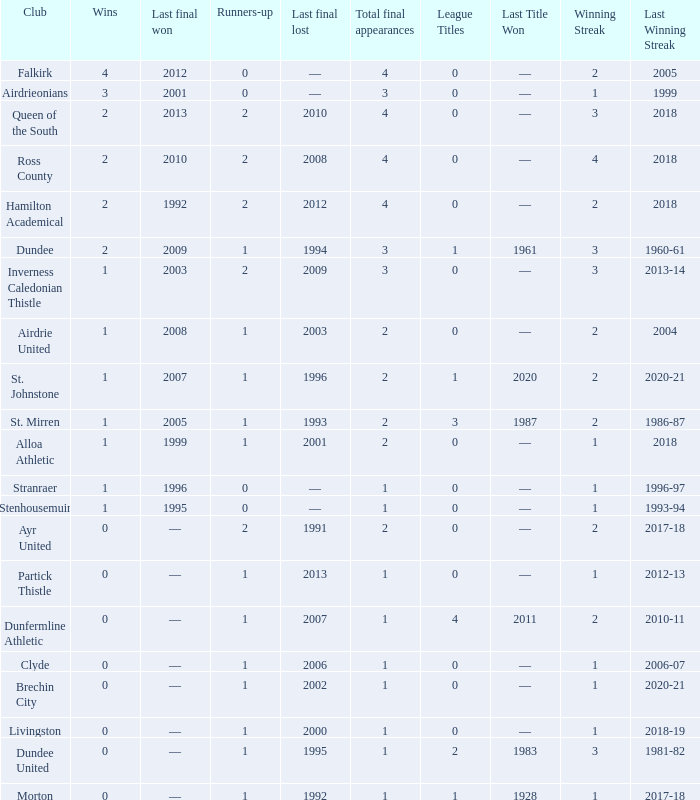What club has over 1 runners-up and last won the final in 2010? Ross County. Parse the full table. {'header': ['Club', 'Wins', 'Last final won', 'Runners-up', 'Last final lost', 'Total final appearances', 'League Titles', 'Last Title Won', 'Winning Streak', 'Last Winning Streak'], 'rows': [['Falkirk', '4', '2012', '0', '—', '4', '0', '—', '2', '2005'], ['Airdrieonians', '3', '2001', '0', '—', '3', '0', '—', '1', '1999'], ['Queen of the South', '2', '2013', '2', '2010', '4', '0', '—', '3', '2018'], ['Ross County', '2', '2010', '2', '2008', '4', '0', '—', '4', '2018'], ['Hamilton Academical', '2', '1992', '2', '2012', '4', '0', '—', '2', '2018'], ['Dundee', '2', '2009', '1', '1994', '3', '1', '1961', '3', '1960-61'], ['Inverness Caledonian Thistle', '1', '2003', '2', '2009', '3', '0', '—', '3', '2013-14'], ['Airdrie United', '1', '2008', '1', '2003', '2', '0', '—', '2', '2004'], ['St. Johnstone', '1', '2007', '1', '1996', '2', '1', '2020', '2', '2020-21'], ['St. Mirren', '1', '2005', '1', '1993', '2', '3', '1987', '2', '1986-87'], ['Alloa Athletic', '1', '1999', '1', '2001', '2', '0', '—', '1', '2018'], ['Stranraer', '1', '1996', '0', '—', '1', '0', '—', '1', '1996-97'], ['Stenhousemuir', '1', '1995', '0', '—', '1', '0', '—', '1', '1993-94'], ['Ayr United', '0', '—', '2', '1991', '2', '0', '—', '2', '2017-18'], ['Partick Thistle', '0', '—', '1', '2013', '1', '0', '—', '1', '2012-13'], ['Dunfermline Athletic', '0', '—', '1', '2007', '1', '4', '2011', '2', '2010-11'], ['Clyde', '0', '—', '1', '2006', '1', '0', '—', '1', '2006-07'], ['Brechin City', '0', '—', '1', '2002', '1', '0', '—', '1', '2020-21'], ['Livingston', '0', '—', '1', '2000', '1', '0', '—', '1', '2018-19'], ['Dundee United', '0', '—', '1', '1995', '1', '2', '1983', '3', '1981-82'], ['Morton', '0', '—', '1', '1992', '1', '1', '1928', '1', '2017-18']]} 